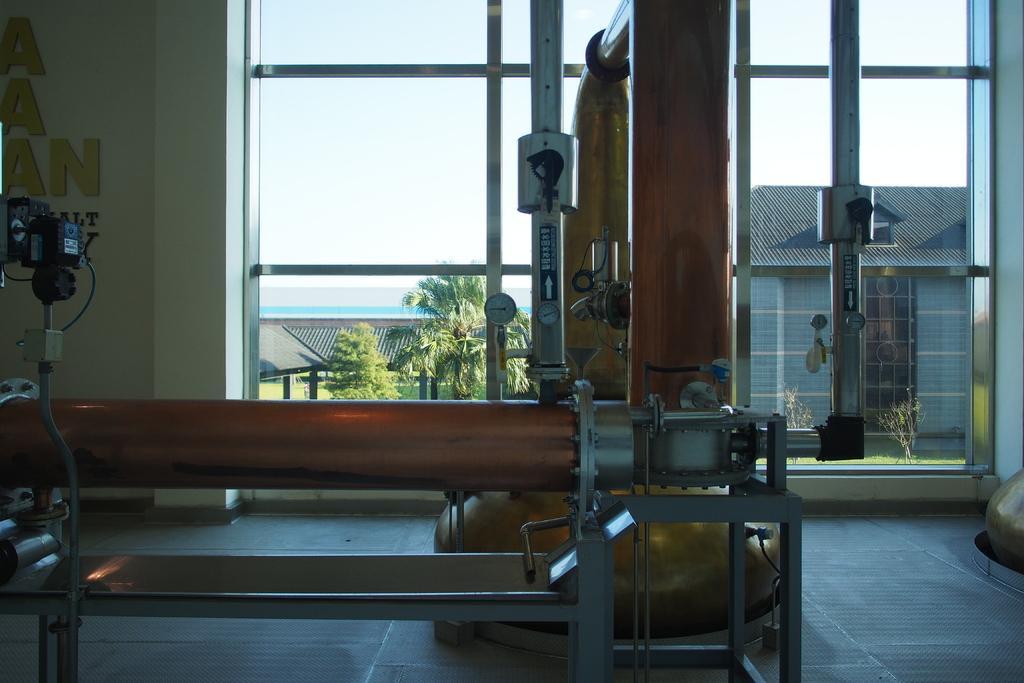Please provide a concise description of this image. This is an inside view of a room. Here I can see few electronic devices are placed on the floor. In the background there is a window and wall. Through the window we can see the outside view. In the outside, I can see few buildings and trees. At the top I can see the sky. 